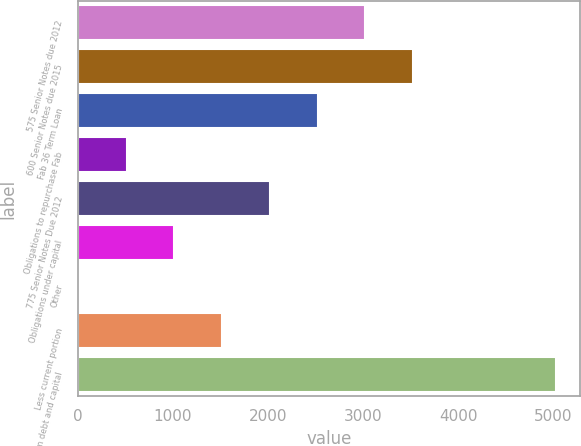Convert chart. <chart><loc_0><loc_0><loc_500><loc_500><bar_chart><fcel>575 Senior Notes due 2012<fcel>600 Senior Notes due 2015<fcel>Fab 36 Term Loan<fcel>Obligations to repurchase Fab<fcel>775 Senior Notes Due 2012<fcel>Obligations under capital<fcel>Other<fcel>Less current portion<fcel>Long-term debt and capital<nl><fcel>3023.4<fcel>3525.3<fcel>2521.5<fcel>513.9<fcel>2019.6<fcel>1015.8<fcel>12<fcel>1517.7<fcel>5031<nl></chart> 